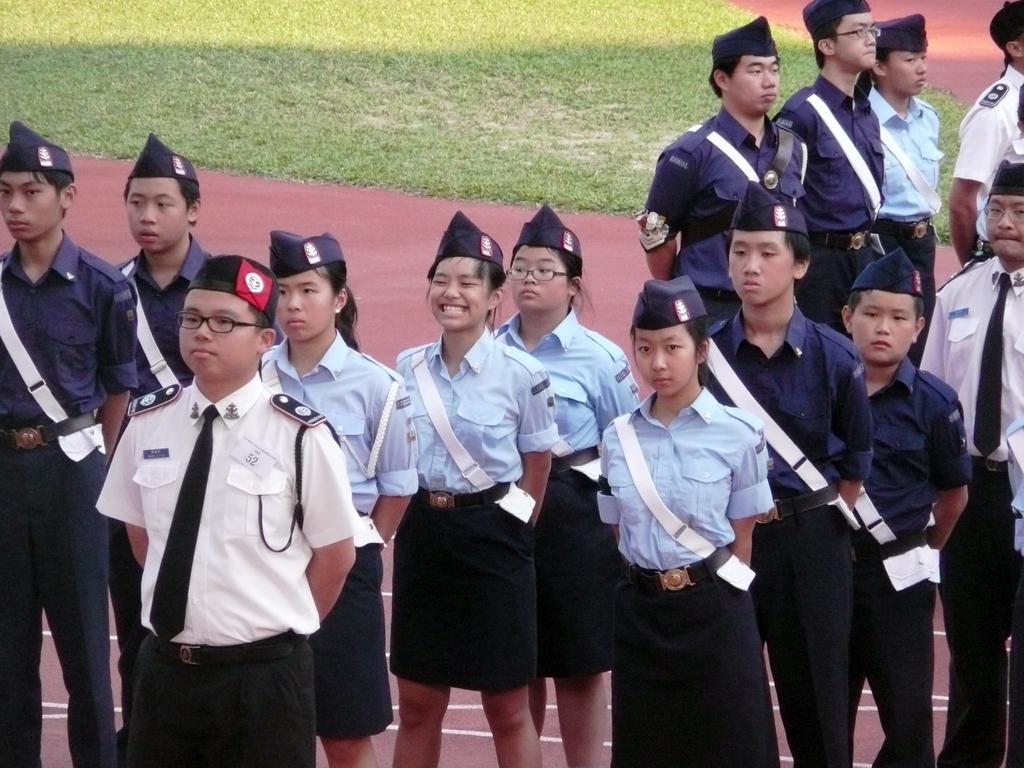Describe this image in one or two sentences. In this image I can see the group of people with white, blue, navy blue and black color dresses. These people are wearing the caps. I can see few people with the specs. In the back I can see the grass. 